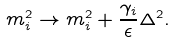<formula> <loc_0><loc_0><loc_500><loc_500>m _ { i } ^ { 2 } \rightarrow m _ { i } ^ { 2 } + \frac { \gamma _ { i } } { \epsilon } \Delta ^ { 2 } .</formula> 